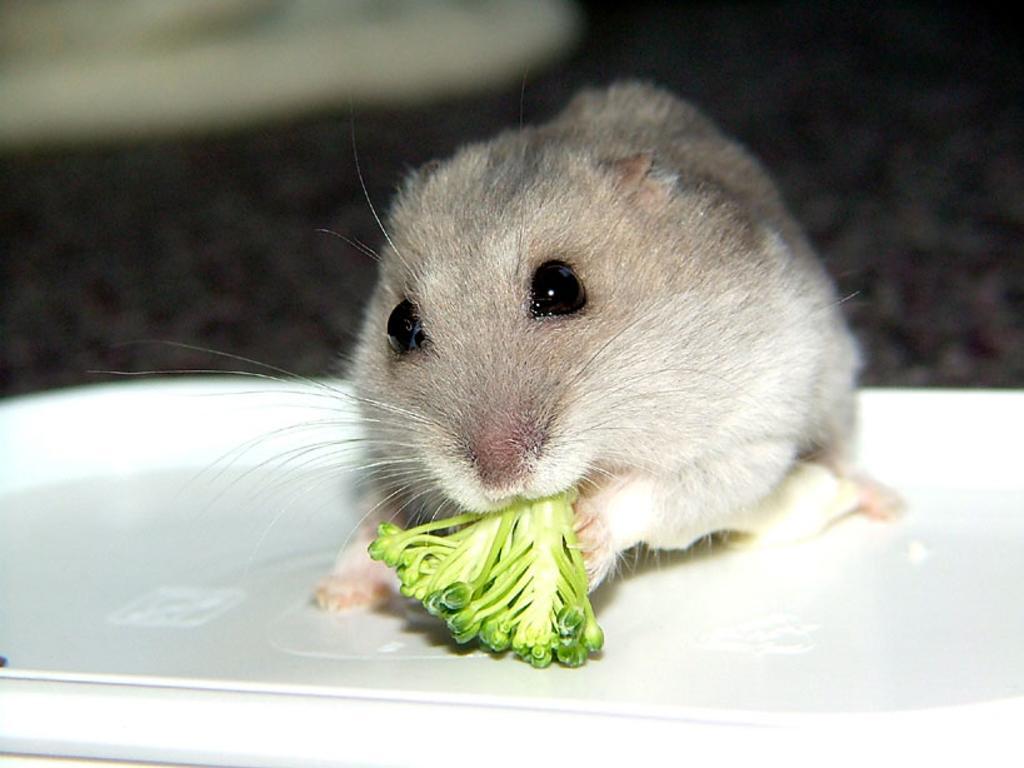Please provide a concise description of this image. The picture consists of a rat, eating some food. The rat is on a plate. The background is blurred. 